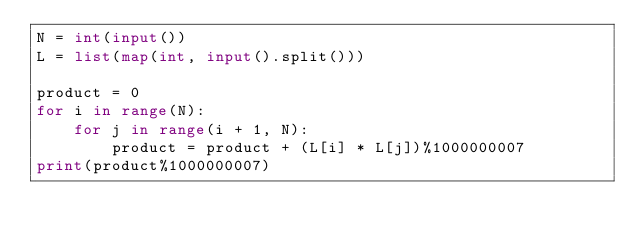<code> <loc_0><loc_0><loc_500><loc_500><_Python_>N = int(input())
L = list(map(int, input().split()))

product = 0
for i in range(N):
    for j in range(i + 1, N):
        product = product + (L[i] * L[j])%1000000007
print(product%1000000007)
</code> 